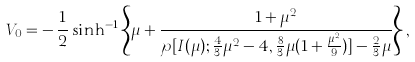Convert formula to latex. <formula><loc_0><loc_0><loc_500><loc_500>V _ { 0 } = - \, \frac { 1 } { 2 } \sinh ^ { - 1 } \left \{ \mu + \frac { 1 + \mu ^ { 2 } } { \wp [ I ( \mu ) ; \frac { 4 } { 3 } \mu ^ { 2 } - 4 , \frac { 8 } { 3 } \mu ( 1 + \frac { \mu ^ { 2 } } { 9 } ) ] - \frac { 2 } { 3 } \mu } \right \} ,</formula> 